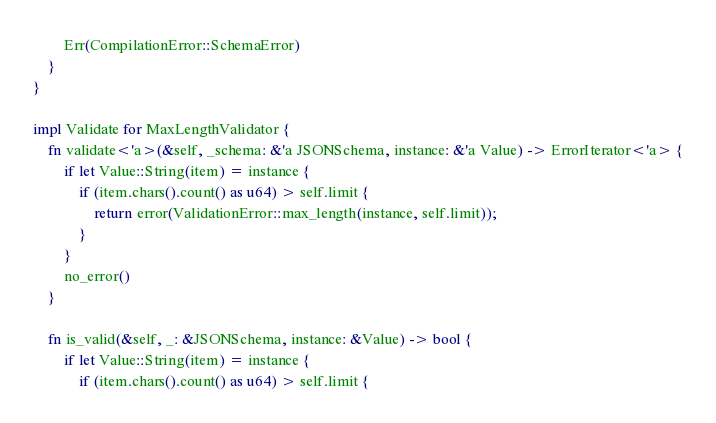Convert code to text. <code><loc_0><loc_0><loc_500><loc_500><_Rust_>        Err(CompilationError::SchemaError)
    }
}

impl Validate for MaxLengthValidator {
    fn validate<'a>(&self, _schema: &'a JSONSchema, instance: &'a Value) -> ErrorIterator<'a> {
        if let Value::String(item) = instance {
            if (item.chars().count() as u64) > self.limit {
                return error(ValidationError::max_length(instance, self.limit));
            }
        }
        no_error()
    }

    fn is_valid(&self, _: &JSONSchema, instance: &Value) -> bool {
        if let Value::String(item) = instance {
            if (item.chars().count() as u64) > self.limit {</code> 